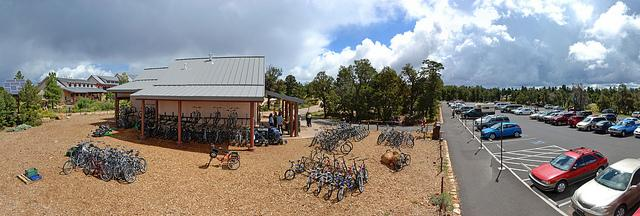What kind of facility can be found nearby? Please explain your reasoning. bike trail. There are many bikes there to ride around on trails and biking paths. 